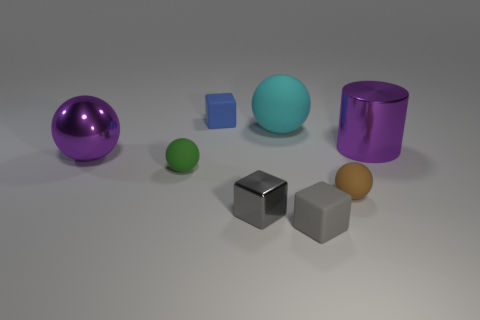There is another tiny sphere that is the same material as the tiny green sphere; what is its color?
Provide a short and direct response. Brown. There is a large ball left of the big cyan object; is its color the same as the metallic cylinder?
Make the answer very short. Yes. There is a small brown thing to the left of the big purple metallic cylinder; what is it made of?
Ensure brevity in your answer.  Rubber. Is the number of green things on the left side of the blue matte cube the same as the number of large red metal things?
Your answer should be very brief. No. How many balls have the same color as the big metallic cylinder?
Your answer should be very brief. 1. What is the color of the other small object that is the same shape as the small green matte object?
Your answer should be very brief. Brown. Does the green ball have the same size as the purple metal ball?
Offer a very short reply. No. Is the number of big cylinders that are behind the small green rubber sphere the same as the number of matte things in front of the brown object?
Ensure brevity in your answer.  Yes. Are there any brown shiny balls?
Your response must be concise. No. There is a purple metallic thing that is the same shape as the green thing; what size is it?
Offer a terse response. Large. 